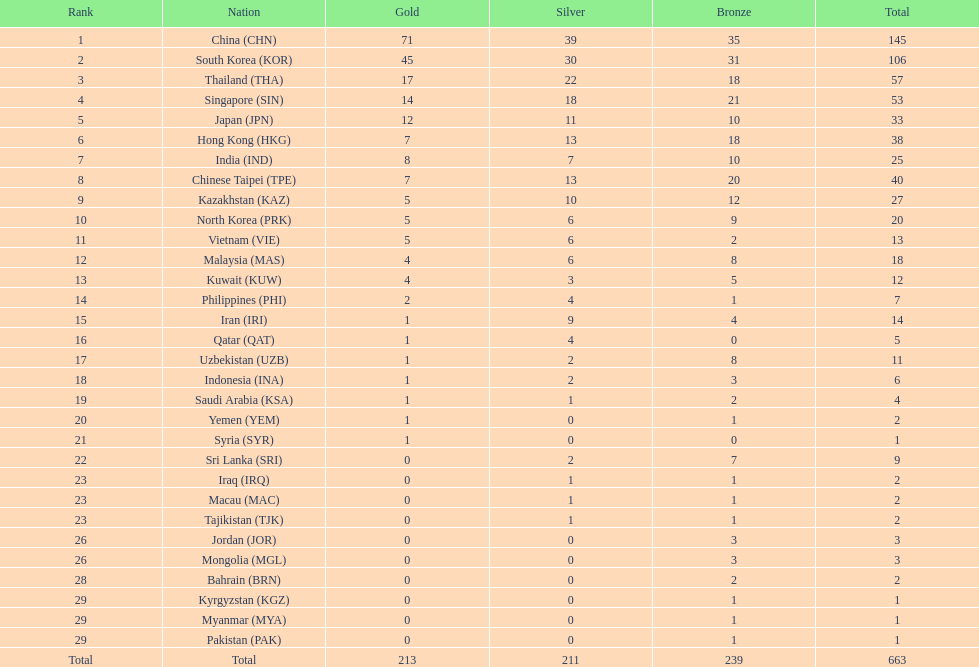How many countries have at least 10 gold medals in the asian youth games? 5. 